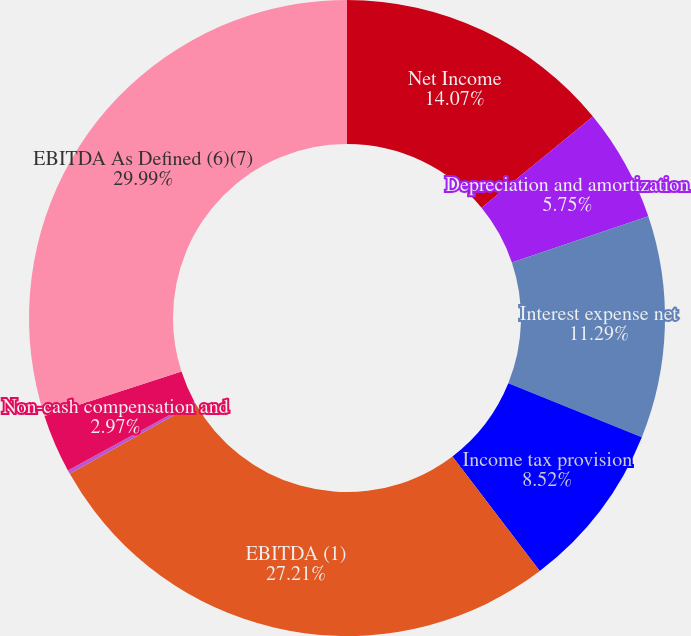Convert chart. <chart><loc_0><loc_0><loc_500><loc_500><pie_chart><fcel>Net Income<fcel>Depreciation and amortization<fcel>Interest expense net<fcel>Income tax provision<fcel>EBITDA (1)<fcel>Acquisition related costs (2)<fcel>Non-cash compensation and<fcel>EBITDA As Defined (6)(7)<nl><fcel>14.07%<fcel>5.75%<fcel>11.29%<fcel>8.52%<fcel>27.21%<fcel>0.2%<fcel>2.97%<fcel>29.98%<nl></chart> 